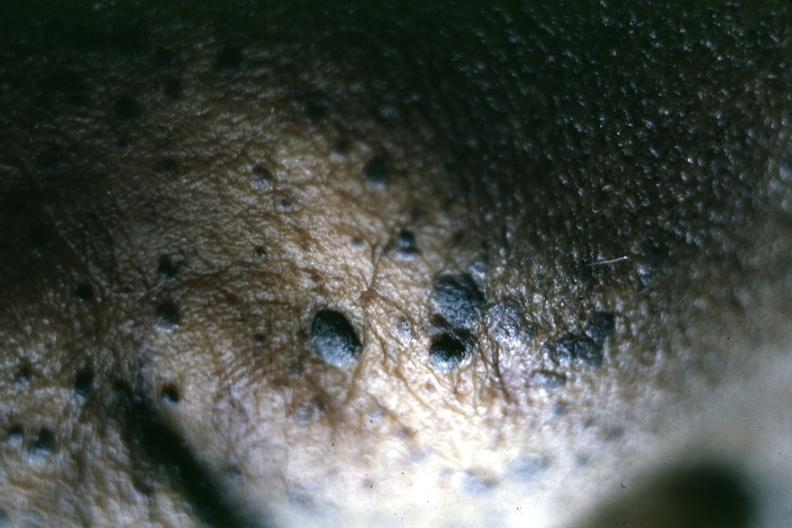s close-up of typical lesions perspective of elevated pasted on lesions well shown?
Answer the question using a single word or phrase. Yes 